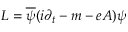<formula> <loc_0><loc_0><loc_500><loc_500>L = \overline { \psi } ( i \partial _ { t } - m - e A ) \psi</formula> 